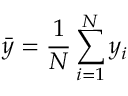<formula> <loc_0><loc_0><loc_500><loc_500>\bar { y } = \frac { 1 } { N } \sum _ { i = 1 } ^ { N } y _ { i }</formula> 